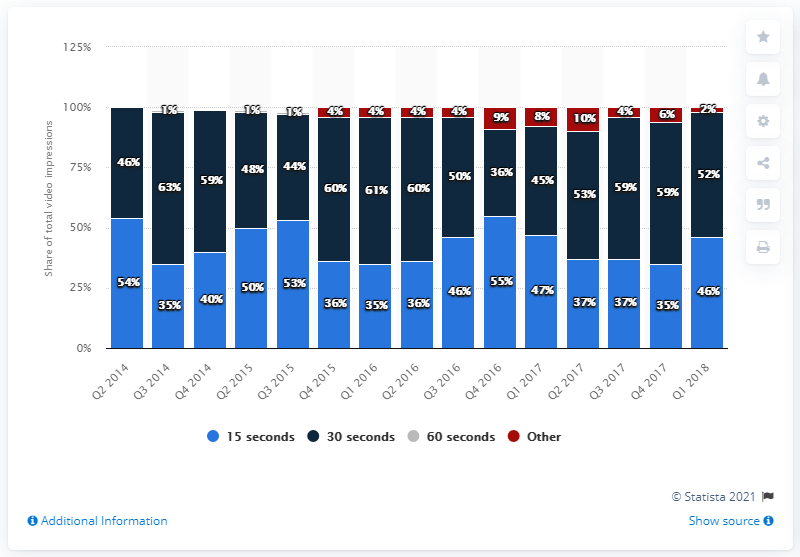Point out several critical features in this image. In the first quarter of 2018, the average length of digital video ads was 15 seconds. 